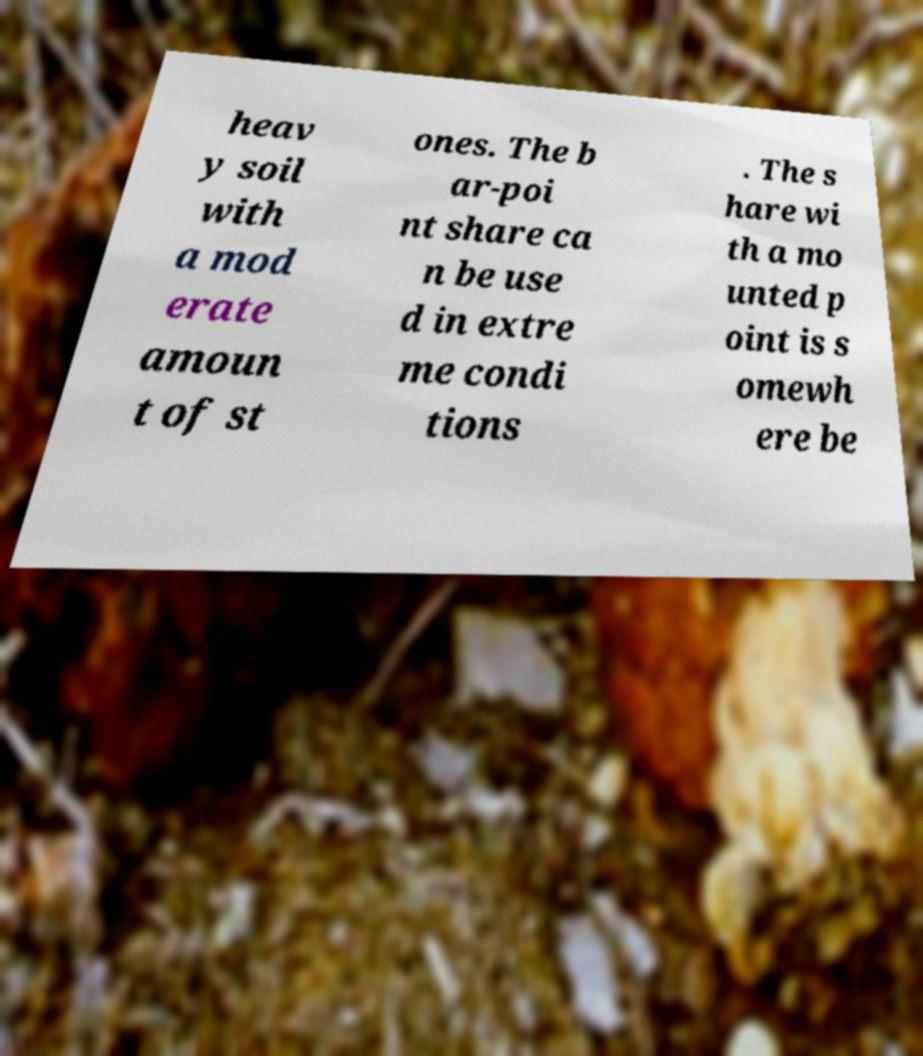For documentation purposes, I need the text within this image transcribed. Could you provide that? heav y soil with a mod erate amoun t of st ones. The b ar-poi nt share ca n be use d in extre me condi tions . The s hare wi th a mo unted p oint is s omewh ere be 